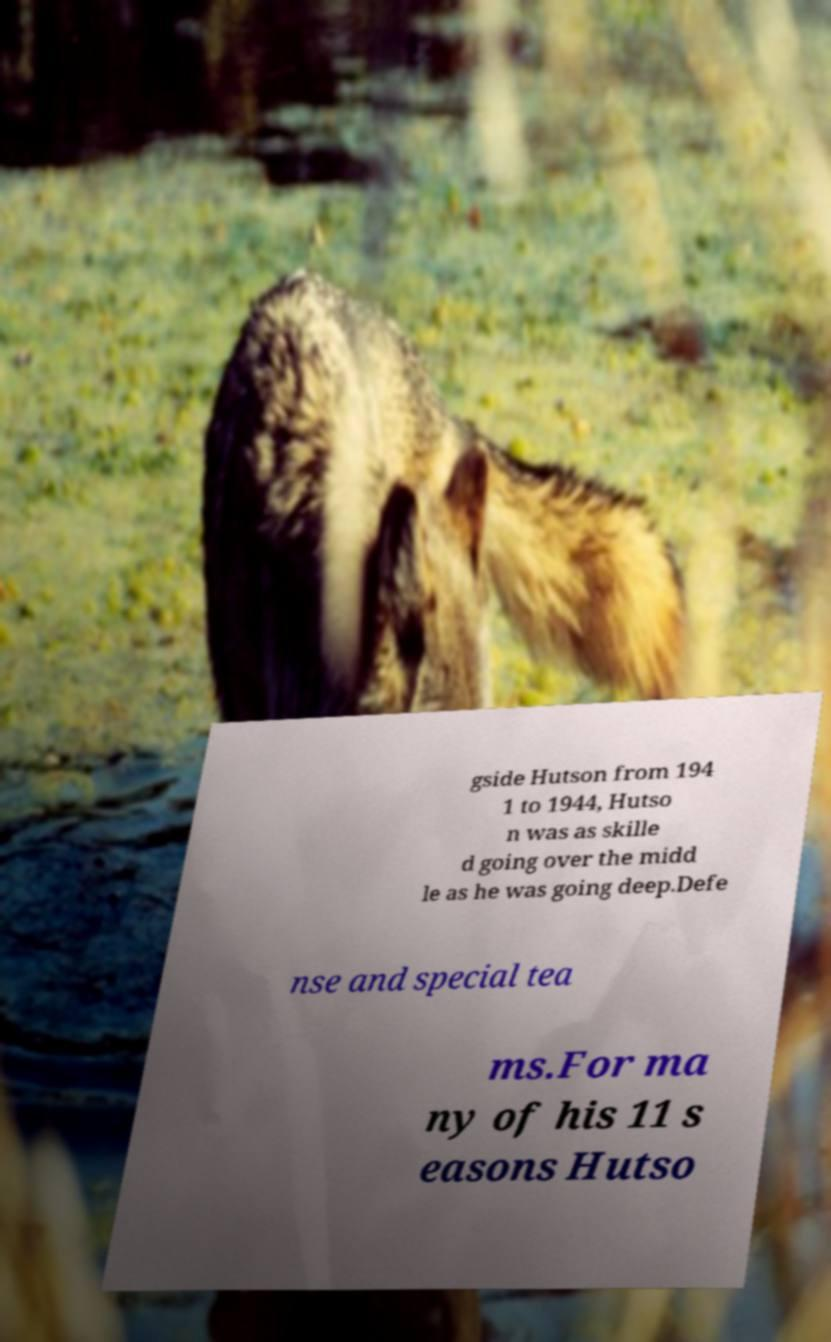Please read and relay the text visible in this image. What does it say? gside Hutson from 194 1 to 1944, Hutso n was as skille d going over the midd le as he was going deep.Defe nse and special tea ms.For ma ny of his 11 s easons Hutso 